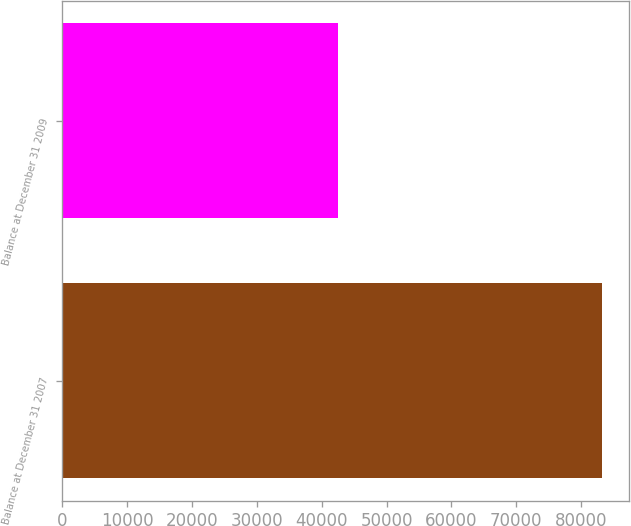<chart> <loc_0><loc_0><loc_500><loc_500><bar_chart><fcel>Balance at December 31 2007<fcel>Balance at December 31 2009<nl><fcel>83238<fcel>42515<nl></chart> 